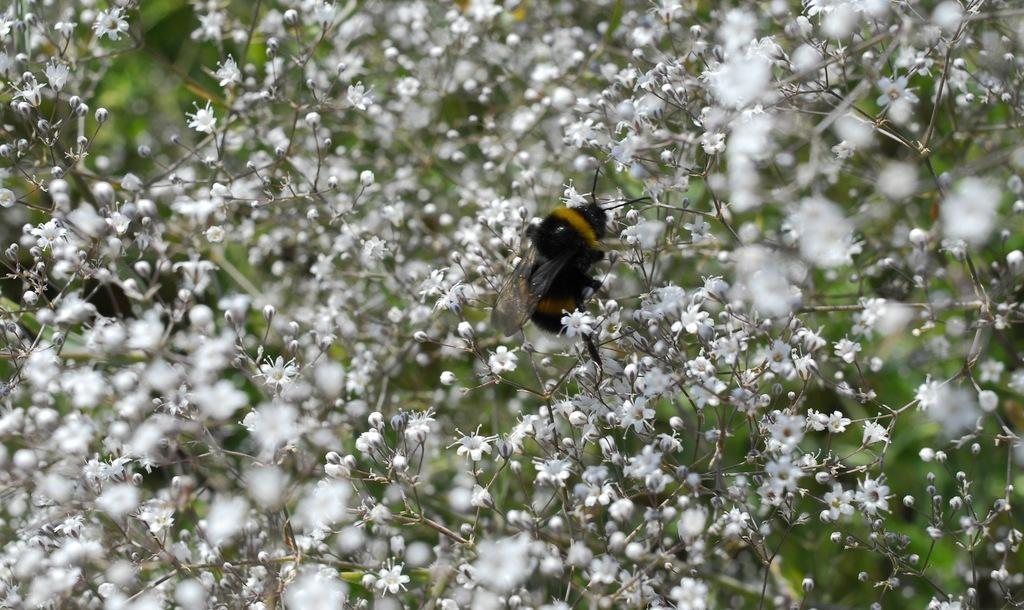What is the main subject in the center of the image? There is an insect in the center of the image. What else can be seen in the image besides the insect? There are many flowers in the image. What type of powder is being used to clean the boot in the image? There is no boot or powder present in the image; it features an insect and many flowers. 